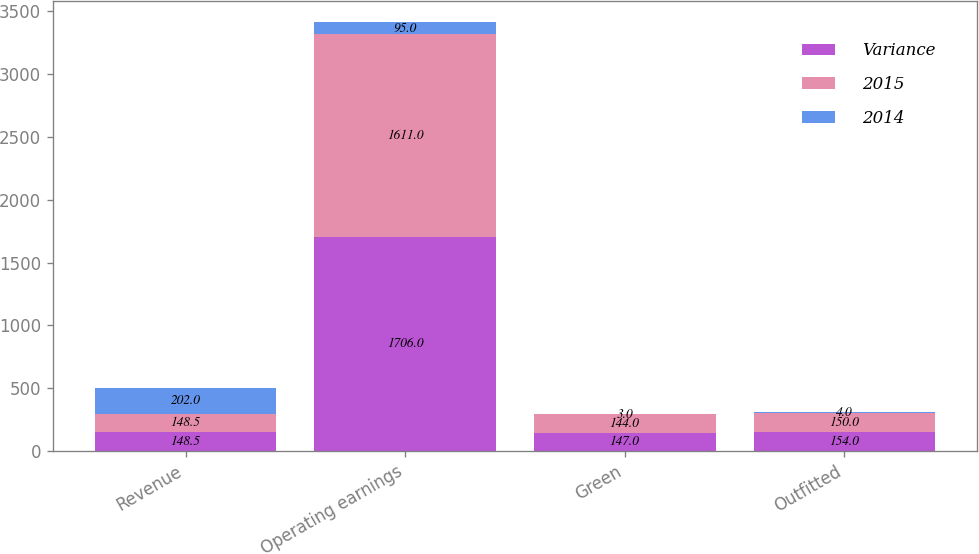Convert chart to OTSL. <chart><loc_0><loc_0><loc_500><loc_500><stacked_bar_chart><ecel><fcel>Revenue<fcel>Operating earnings<fcel>Green<fcel>Outfitted<nl><fcel>Variance<fcel>148.5<fcel>1706<fcel>147<fcel>154<nl><fcel>2015<fcel>148.5<fcel>1611<fcel>144<fcel>150<nl><fcel>2014<fcel>202<fcel>95<fcel>3<fcel>4<nl></chart> 